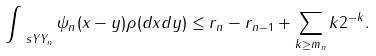<formula> <loc_0><loc_0><loc_500><loc_500>\int _ { \ s Y Y _ { n } } \psi _ { n } ( \| x - y \| ) \rho ( d x d y ) \leq r _ { n } - r _ { n - 1 } + \sum _ { k \geq m _ { n } } k 2 ^ { - k } .</formula> 